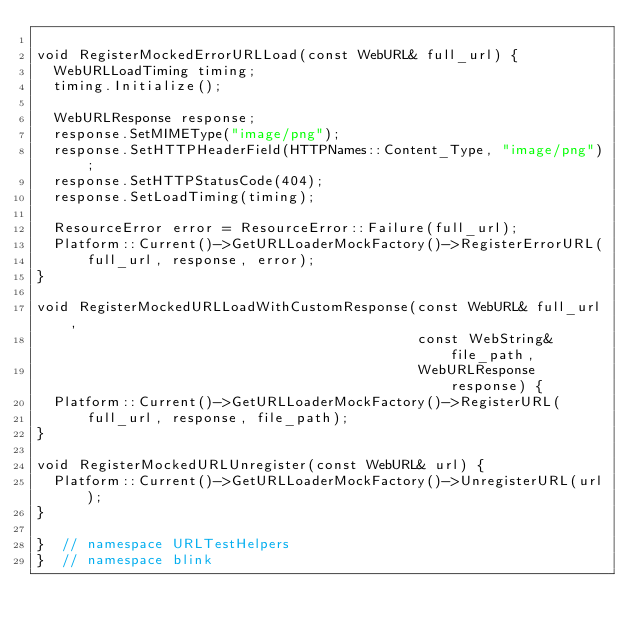Convert code to text. <code><loc_0><loc_0><loc_500><loc_500><_C++_>
void RegisterMockedErrorURLLoad(const WebURL& full_url) {
  WebURLLoadTiming timing;
  timing.Initialize();

  WebURLResponse response;
  response.SetMIMEType("image/png");
  response.SetHTTPHeaderField(HTTPNames::Content_Type, "image/png");
  response.SetHTTPStatusCode(404);
  response.SetLoadTiming(timing);

  ResourceError error = ResourceError::Failure(full_url);
  Platform::Current()->GetURLLoaderMockFactory()->RegisterErrorURL(
      full_url, response, error);
}

void RegisterMockedURLLoadWithCustomResponse(const WebURL& full_url,
                                             const WebString& file_path,
                                             WebURLResponse response) {
  Platform::Current()->GetURLLoaderMockFactory()->RegisterURL(
      full_url, response, file_path);
}

void RegisterMockedURLUnregister(const WebURL& url) {
  Platform::Current()->GetURLLoaderMockFactory()->UnregisterURL(url);
}

}  // namespace URLTestHelpers
}  // namespace blink
</code> 